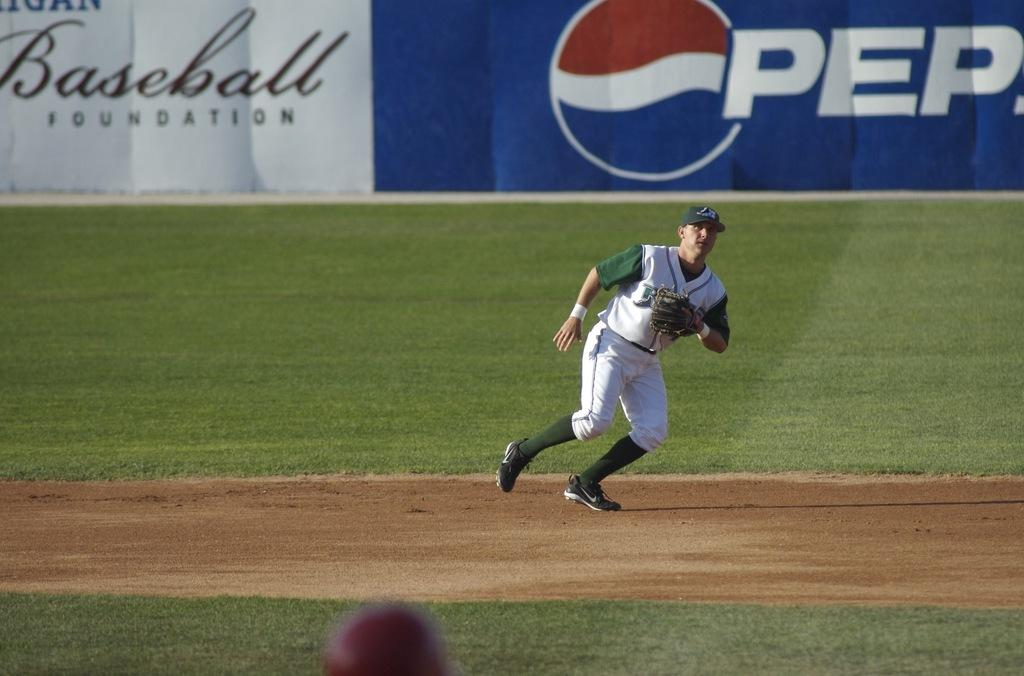<image>
Describe the image concisely. A baseball player on the field with a Pepsi ad in the background. 